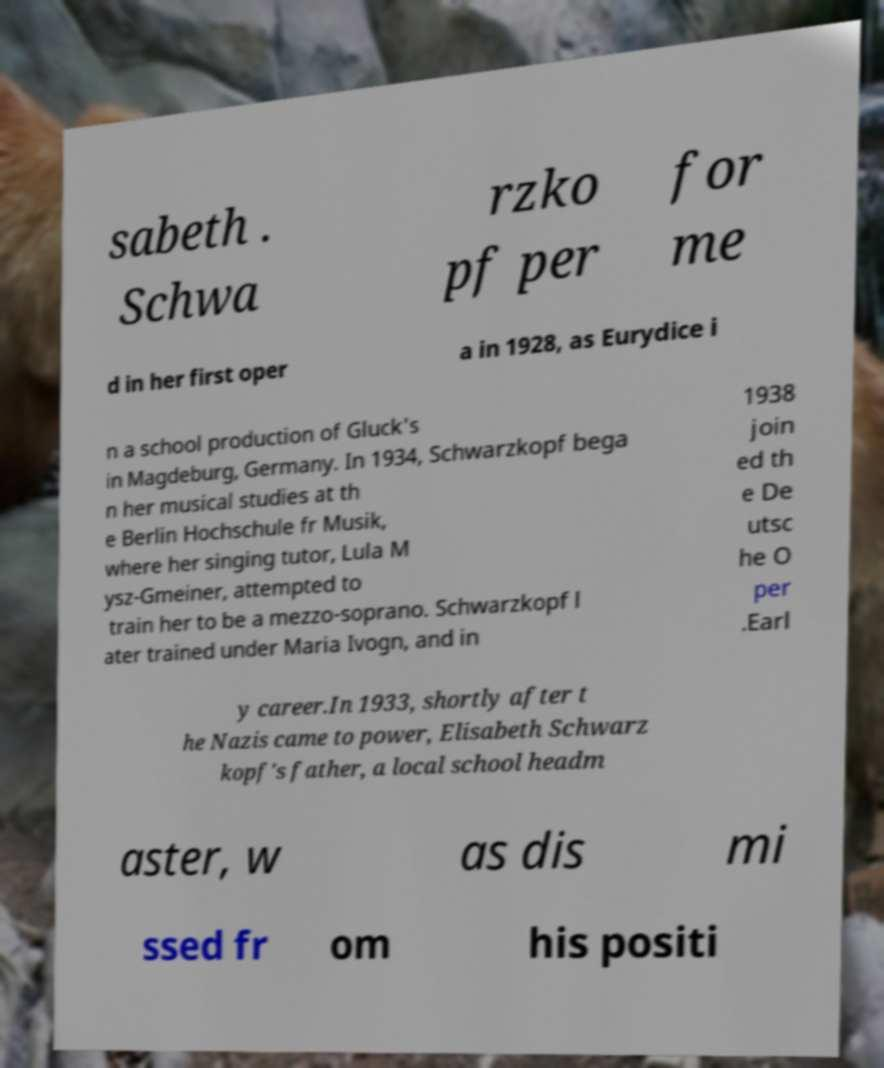Could you extract and type out the text from this image? sabeth . Schwa rzko pf per for me d in her first oper a in 1928, as Eurydice i n a school production of Gluck's in Magdeburg, Germany. In 1934, Schwarzkopf bega n her musical studies at th e Berlin Hochschule fr Musik, where her singing tutor, Lula M ysz-Gmeiner, attempted to train her to be a mezzo-soprano. Schwarzkopf l ater trained under Maria Ivogn, and in 1938 join ed th e De utsc he O per .Earl y career.In 1933, shortly after t he Nazis came to power, Elisabeth Schwarz kopf's father, a local school headm aster, w as dis mi ssed fr om his positi 